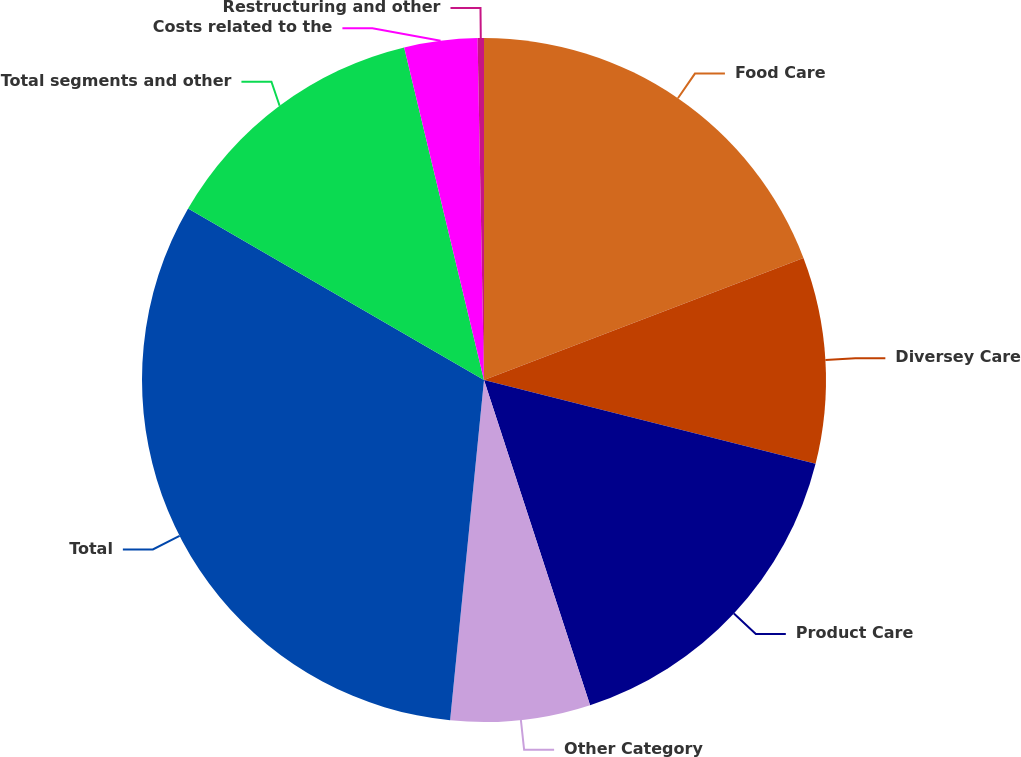Convert chart to OTSL. <chart><loc_0><loc_0><loc_500><loc_500><pie_chart><fcel>Food Care<fcel>Diversey Care<fcel>Product Care<fcel>Other Category<fcel>Total<fcel>Total segments and other<fcel>Costs related to the<fcel>Restructuring and other<nl><fcel>19.19%<fcel>9.75%<fcel>16.04%<fcel>6.6%<fcel>31.78%<fcel>12.89%<fcel>3.45%<fcel>0.3%<nl></chart> 